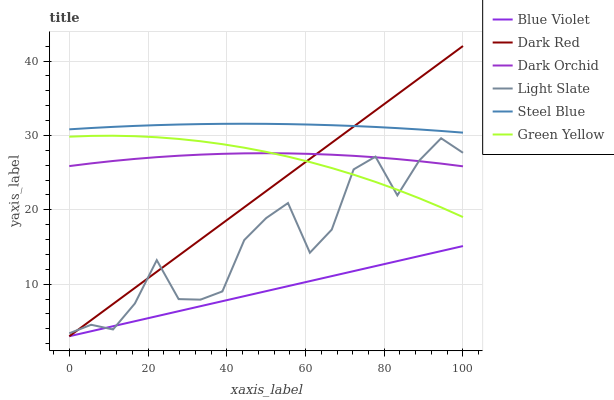Does Dark Red have the minimum area under the curve?
Answer yes or no. No. Does Dark Red have the maximum area under the curve?
Answer yes or no. No. Is Dark Red the smoothest?
Answer yes or no. No. Is Dark Red the roughest?
Answer yes or no. No. Does Steel Blue have the lowest value?
Answer yes or no. No. Does Steel Blue have the highest value?
Answer yes or no. No. Is Green Yellow less than Steel Blue?
Answer yes or no. Yes. Is Steel Blue greater than Dark Orchid?
Answer yes or no. Yes. Does Green Yellow intersect Steel Blue?
Answer yes or no. No. 